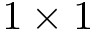<formula> <loc_0><loc_0><loc_500><loc_500>1 \times 1</formula> 